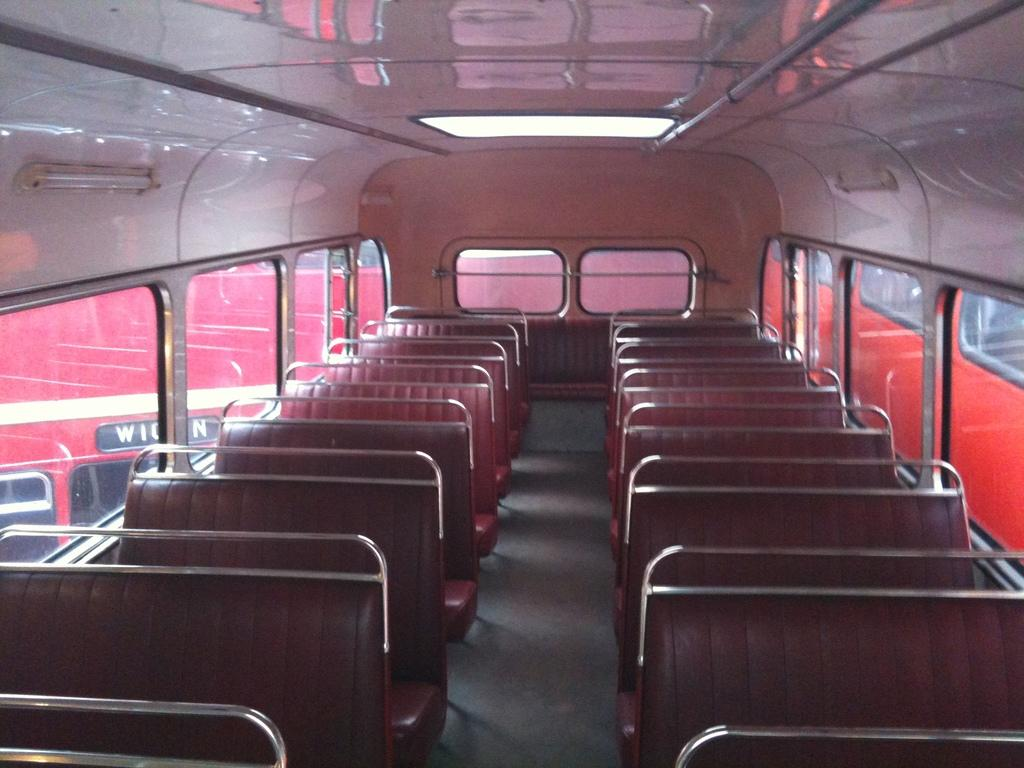Where was the image taken? The image was taken inside a bus. What can be found inside the bus? There are seats in the bus. What can be seen outside the bus through the windows? The path outside the bus is visible. What type of windows are in the bus? There are glass windows in the bus. What else can be seen through the glass windows? Other vehicles are visible through the glass windows. What type of flooring can be seen in the image? There is no information about the flooring in the image, as the focus is on the interior of the bus and the view outside. --- Facts: 1. There is a person holding a camera in the image. 2. The person is wearing a hat. 3. The person is standing near a tree. 4. The tree has green leaves. 5. The sky is visible in the background. Absurd Topics: parrot, sand, ocean Conversation: What is the person in the image doing? The person in the image is holding a camera. What can be seen on the person's head? The person is wearing a hat. Where is the person standing in relation to the tree? The person is standing near a tree. What is the condition of the tree's leaves? The tree has green leaves. What can be seen in the background of the image? The sky is visible in the background. Reasoning: Let's think step by step in order to produce the conversation. We start by identifying the main subject in the image, which is the person holding a camera. Then, we describe the person's attire, focusing on the hat. Next, we mention the person's location in relation to the tree. We then describe the tree's appearance, focusing on the green leaves. Finally, we mention the view in the background, which is the sky. Absurd Question/Answer: What type of parrot can be seen perched on the tree in the image? There is no parrot present in the image; it only features a person holding a camera, a tree with green leaves, and the sky in the background. --- Facts: 1. There is a person sitting on a bench in the image. 2. The person is reading a book. 3. The bench is located near a body of water. 4. There are trees in the background. 5. The sky is visible in the background. Absurd Topics: bicycle, sandcastle, volcano Conversation: What is the person in the image doing? The person in the image is sitting on a bench and reading a book. Where is the bench located? The bench is located near a body of water. What can be seen in the background of the image? There are trees and the sky visible in the background. 